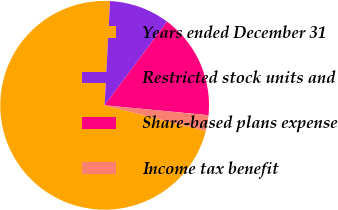Convert chart to OTSL. <chart><loc_0><loc_0><loc_500><loc_500><pie_chart><fcel>Years ended December 31<fcel>Restricted stock units and<fcel>Share-based plans expense<fcel>Income tax benefit<nl><fcel>71.88%<fcel>9.37%<fcel>16.32%<fcel>2.43%<nl></chart> 